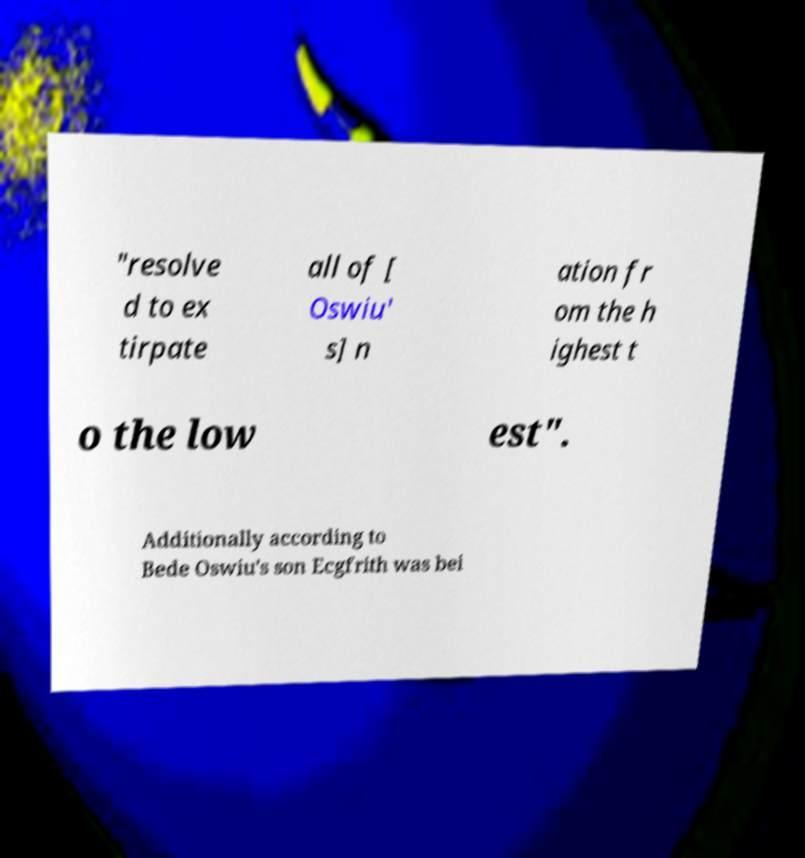Please identify and transcribe the text found in this image. "resolve d to ex tirpate all of [ Oswiu' s] n ation fr om the h ighest t o the low est". Additionally according to Bede Oswiu's son Ecgfrith was bei 